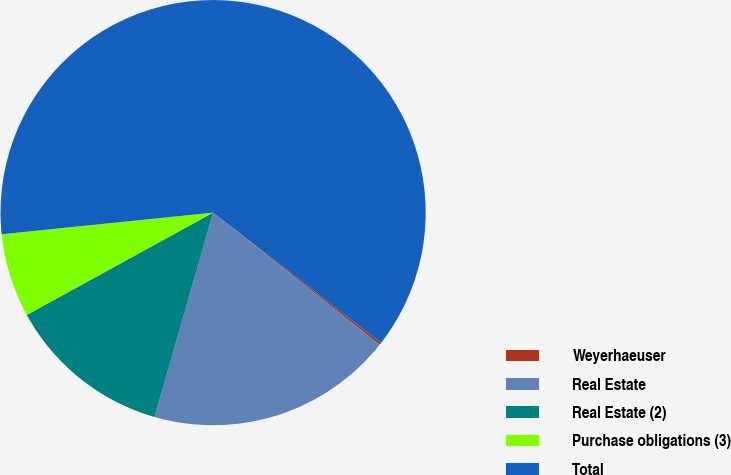Convert chart. <chart><loc_0><loc_0><loc_500><loc_500><pie_chart><fcel>Weyerhaeuser<fcel>Real Estate<fcel>Real Estate (2)<fcel>Purchase obligations (3)<fcel>Total<nl><fcel>0.18%<fcel>18.76%<fcel>12.57%<fcel>6.37%<fcel>62.13%<nl></chart> 